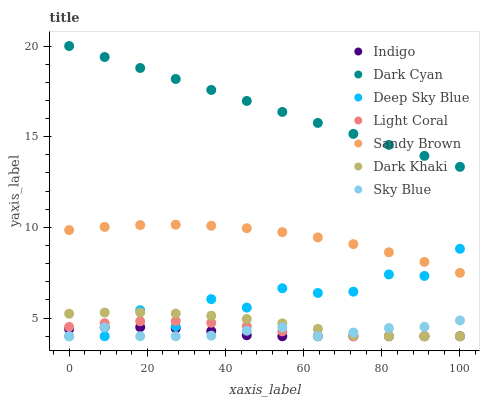Does Indigo have the minimum area under the curve?
Answer yes or no. Yes. Does Dark Cyan have the maximum area under the curve?
Answer yes or no. Yes. Does Light Coral have the minimum area under the curve?
Answer yes or no. No. Does Light Coral have the maximum area under the curve?
Answer yes or no. No. Is Dark Cyan the smoothest?
Answer yes or no. Yes. Is Deep Sky Blue the roughest?
Answer yes or no. Yes. Is Indigo the smoothest?
Answer yes or no. No. Is Indigo the roughest?
Answer yes or no. No. Does Dark Khaki have the lowest value?
Answer yes or no. Yes. Does Dark Cyan have the lowest value?
Answer yes or no. No. Does Dark Cyan have the highest value?
Answer yes or no. Yes. Does Light Coral have the highest value?
Answer yes or no. No. Is Dark Khaki less than Dark Cyan?
Answer yes or no. Yes. Is Dark Cyan greater than Deep Sky Blue?
Answer yes or no. Yes. Does Light Coral intersect Sky Blue?
Answer yes or no. Yes. Is Light Coral less than Sky Blue?
Answer yes or no. No. Is Light Coral greater than Sky Blue?
Answer yes or no. No. Does Dark Khaki intersect Dark Cyan?
Answer yes or no. No. 